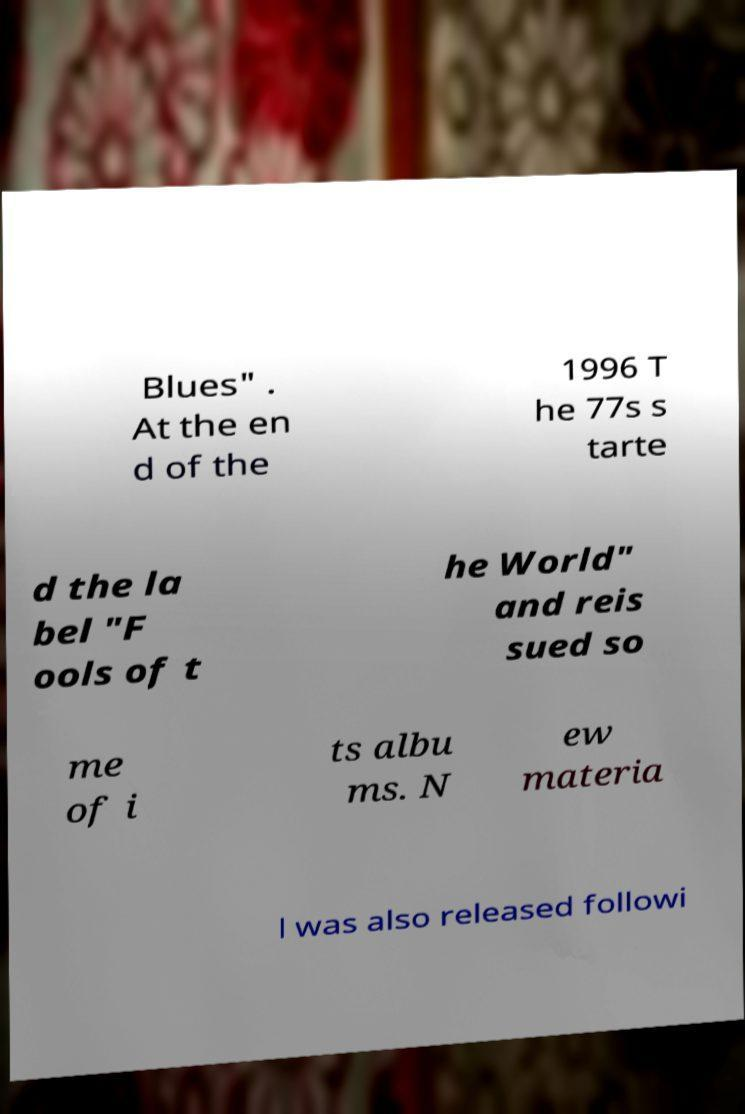Please identify and transcribe the text found in this image. Blues" . At the en d of the 1996 T he 77s s tarte d the la bel "F ools of t he World" and reis sued so me of i ts albu ms. N ew materia l was also released followi 